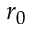Convert formula to latex. <formula><loc_0><loc_0><loc_500><loc_500>r _ { 0 }</formula> 